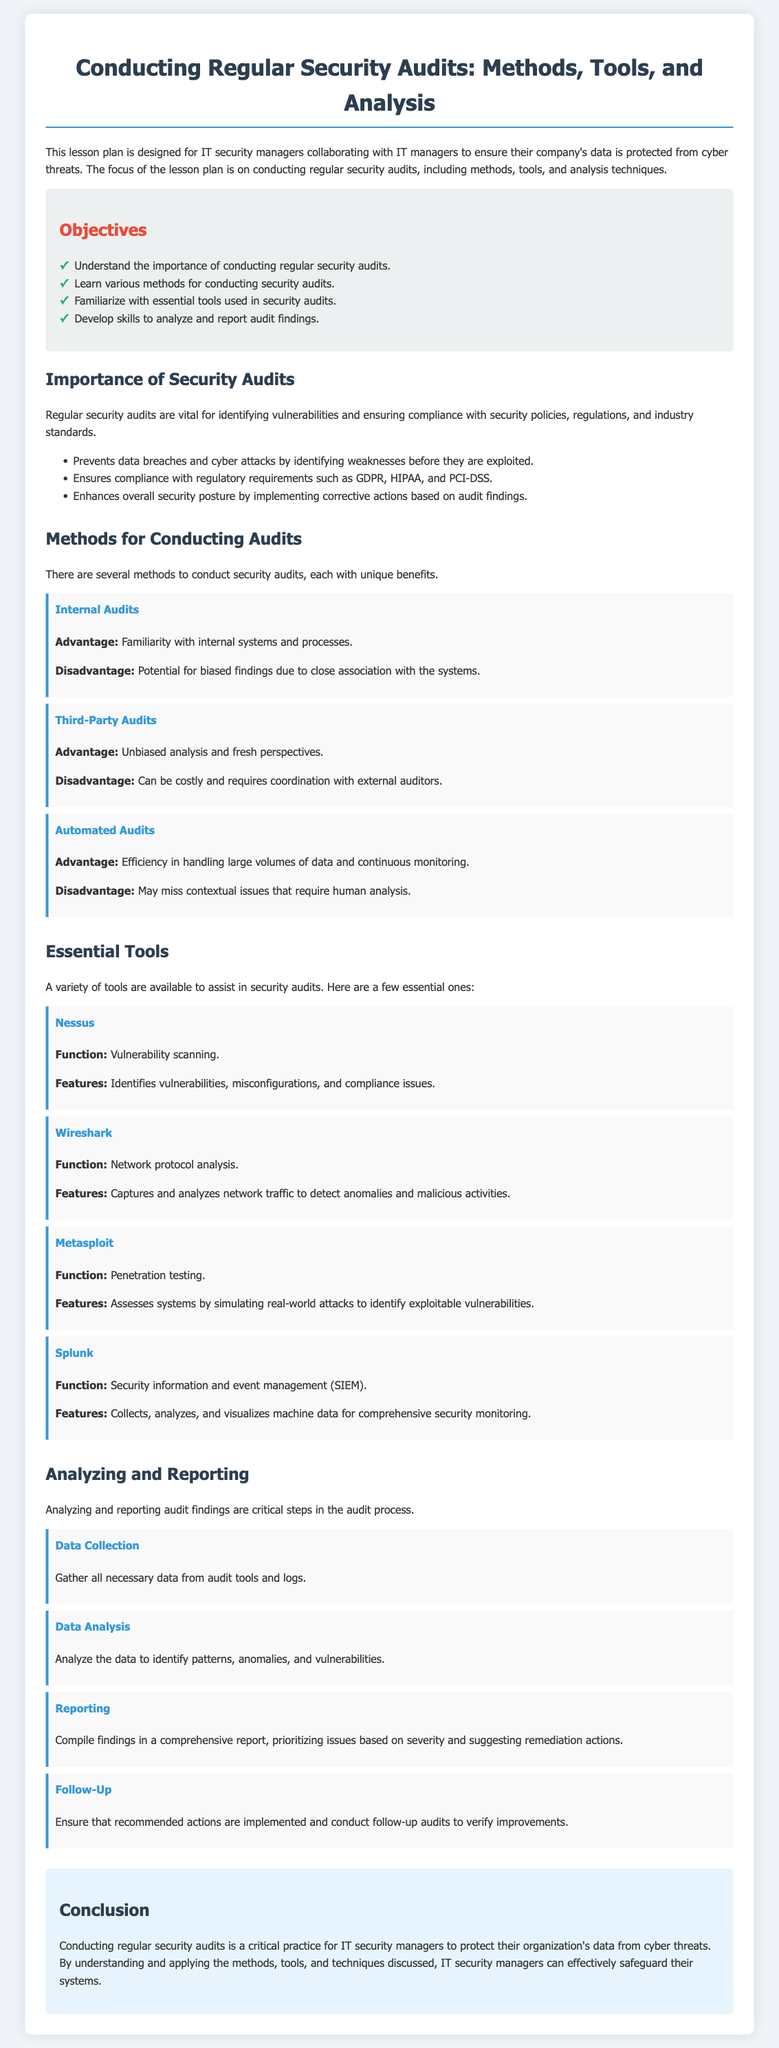what is the title of the lesson plan? The title of the lesson plan is clearly stated at the beginning of the document.
Answer: Conducting Regular Security Audits: Methods, Tools, and Analysis what are the benefits of regular security audits? The document lists benefits under its importance section, specifically highlighting how audits help in security.
Answer: Identifying vulnerabilities, ensuring compliance, enhancing security posture how many methods for conducting audits are mentioned? The methods for conducting audits are listed in a specific section of the document.
Answer: Three name one essential tool used for security audits. The document provides examples of essential tools in a dedicated section.
Answer: Nessus what is the function of Wireshark? The document specifies the function of Wireshark in the tools section.
Answer: Network protocol analysis what step comes after data analysis in the reporting process? The document outlines the steps in the analyzing and reporting section, detailing the order of actions.
Answer: Reporting what are the objectives of the lesson plan? The objectives of the lesson plan are listed in a separate section, outlining key learning points.
Answer: Understand importance, learn methods, familiarize with tools, develop skills which auditing method is associated with unbiased analysis? The advantages of different auditing methods are described, allowing reasoning to determine which is unbiased.
Answer: Third-Party Audits 